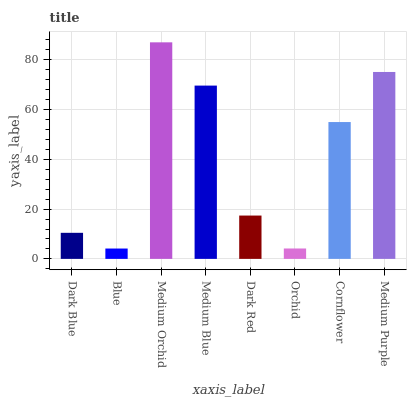Is Medium Orchid the minimum?
Answer yes or no. No. Is Blue the maximum?
Answer yes or no. No. Is Medium Orchid greater than Blue?
Answer yes or no. Yes. Is Blue less than Medium Orchid?
Answer yes or no. Yes. Is Blue greater than Medium Orchid?
Answer yes or no. No. Is Medium Orchid less than Blue?
Answer yes or no. No. Is Cornflower the high median?
Answer yes or no. Yes. Is Dark Red the low median?
Answer yes or no. Yes. Is Medium Orchid the high median?
Answer yes or no. No. Is Medium Blue the low median?
Answer yes or no. No. 